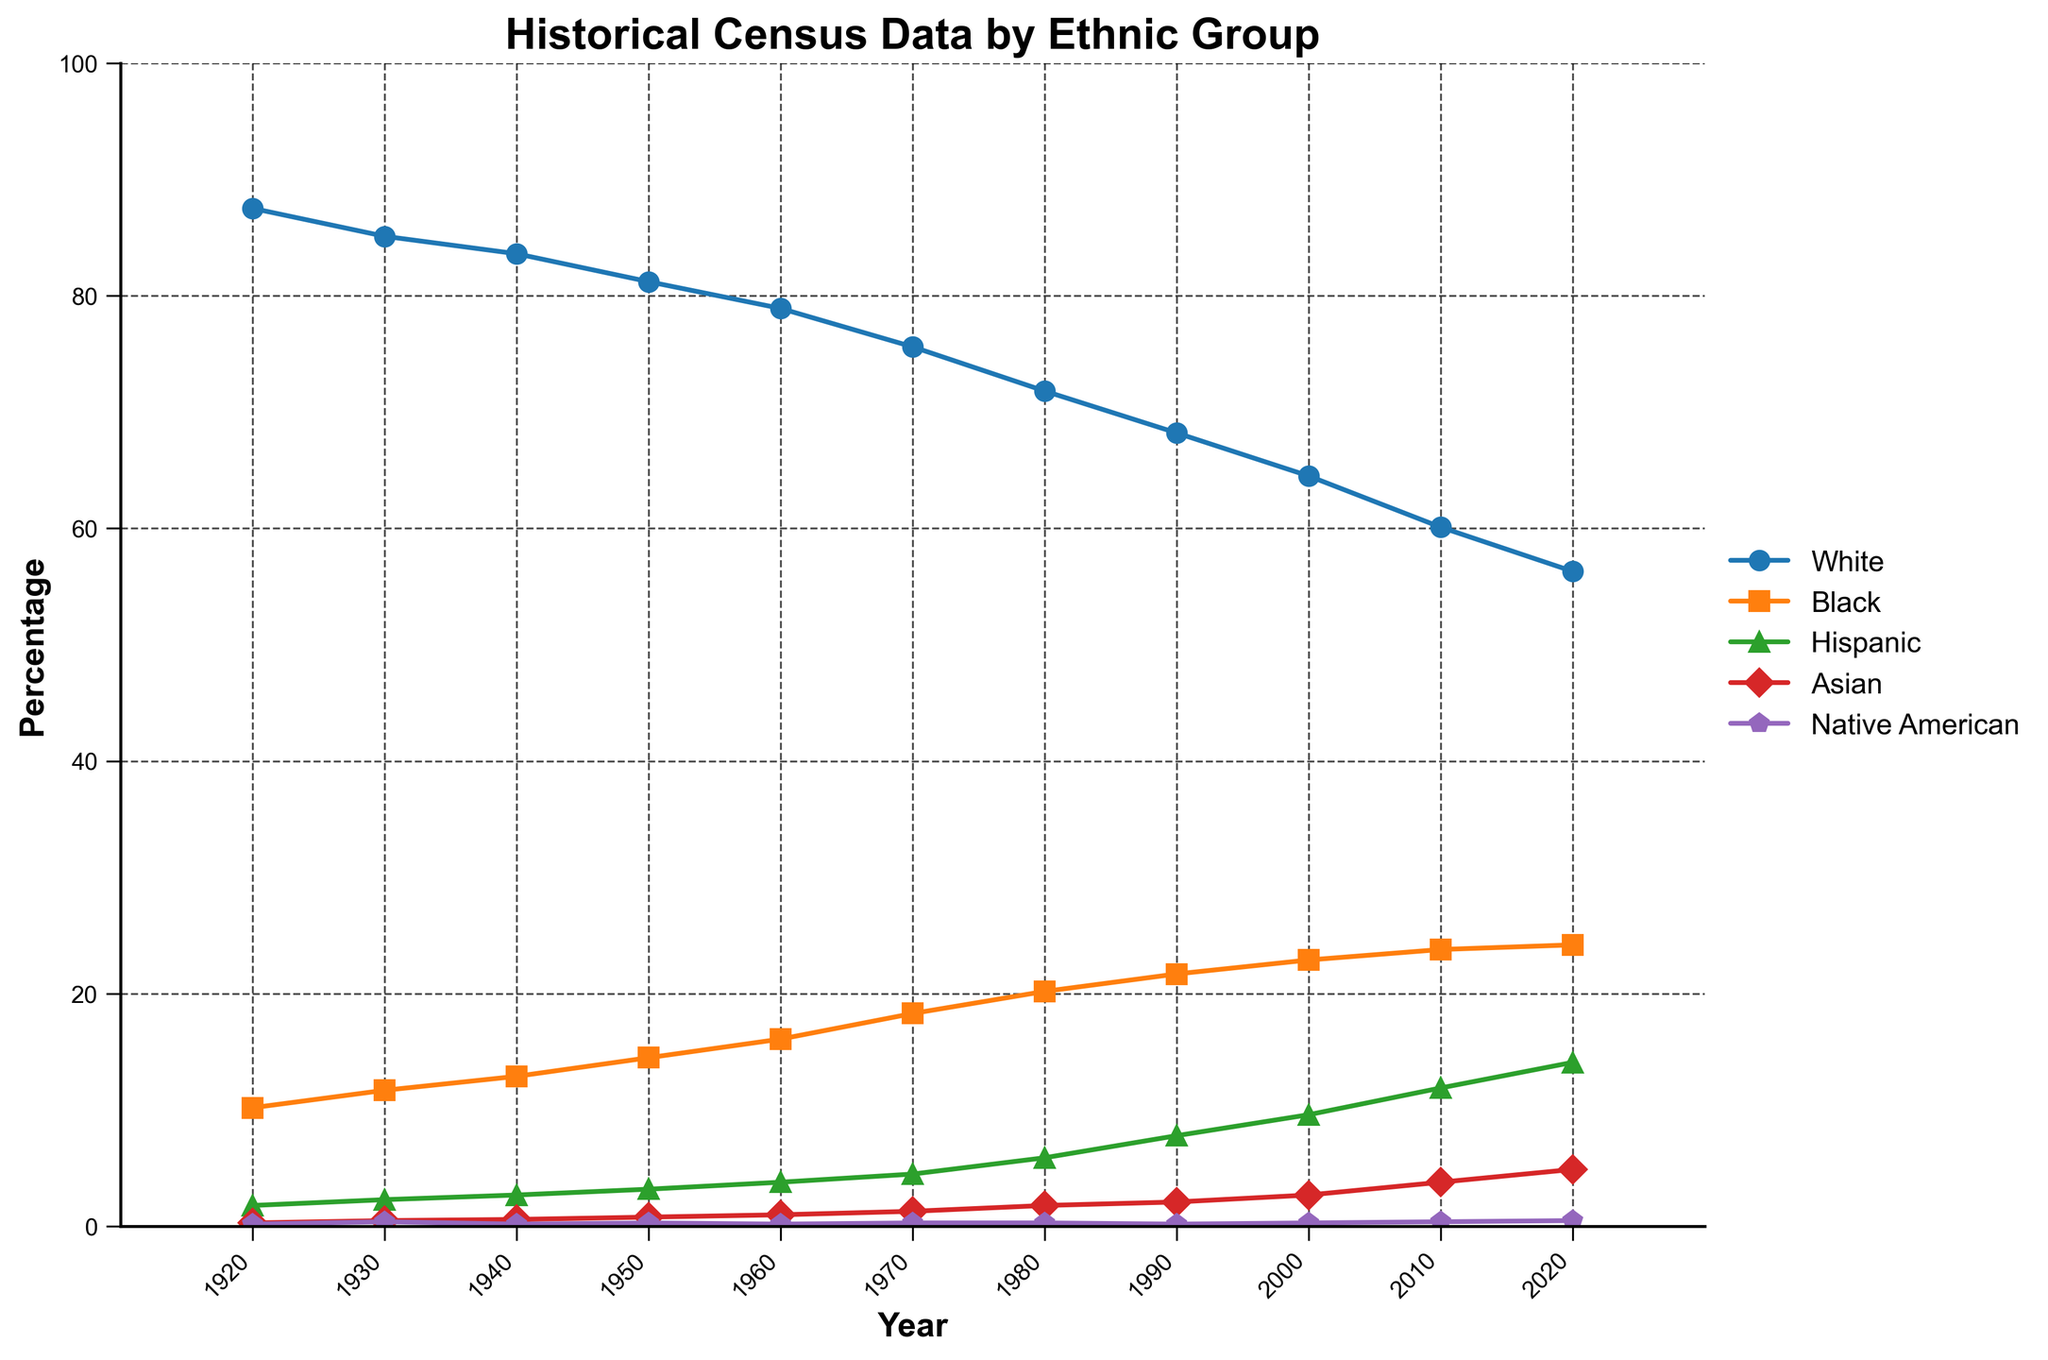What trends can you observe in the percentage of the White and Hispanic populations from 1920 to 2020? The percentage of the White population shows a decreasing trend, starting at 87.5% in 1920 and dropping to 56.3% in 2020. Conversely, the Hispanic population shows an increasing trend, starting at 1.8% in 1920 and rising to 14.1% by 2020.
Answer: White decreases; Hispanic increases Which ethnic group had the most significant percentage increase between 1920 and 2020? The Hispanic group shows the most significant percentage increase, rising from 1.8% in 1920 to 14.1% in 2020, an increase of 12.3 percentage points.
Answer: Hispanic In what year did the Black population surpass 20%? Reviewing the line representing the Black population, it crosses the 20% mark between 1970 and 1980. In 1980, it reached 20.2%.
Answer: 1980 How does the percentage of the Native American population in 2020 compare to that in 1920? The percentage of the Native American population increases slightly from 0.2% in 1920 to 0.5% in 2020.
Answer: Slight increase What is the difference in percentage points between the White and Black populations in 2020? In 2020, the White population is 56.3%, and the Black population is 24.2%. The difference is 56.3% - 24.2% = 32.1 percentage points.
Answer: 32.1 Did the Asian population percentage exceed 4% before 2000? Based on the data, the Asian population percentage stayed below 4% until it reached 4.9% in 2020, and it was 3.8% in 2010.
Answer: No Identify the period when the percentage of the White population had the steepest decline. The steepest decline for the White population can be observed between 2010 and 2020, where it drops from 60.1% to 56.3%, a decrease of 3.8 percentage points.
Answer: 2010-2020 Which ethnic group had the smallest change in percentage over the century? The Native American population changed from 0.2% in 1920 to 0.5% in 2020, a change of just 0.3 percentage points, which is the smallest change among the groups.
Answer: Native American What is the average percentage of the Hispanic population over the century? Sum the percentages from 1920 to 2020 and divide by the number of data points: (1.8 + 2.3 + 2.7 + 3.2 + 3.8 + 4.5 + 5.9 + 7.8 + 9.6 + 11.9 + 14.1)/11 = 6.05%.
Answer: 6.05 How many times and in which decades did the Black population experience percentage increases greater than 2%? Reviewing the data, the Black population grew more than 2% in three decades: 1940-1950 (2.6%), 1950-1960 (2.2%), and 1960-1970 (2.2%).
Answer: Three times: 1940s, 1950s, 1960s 